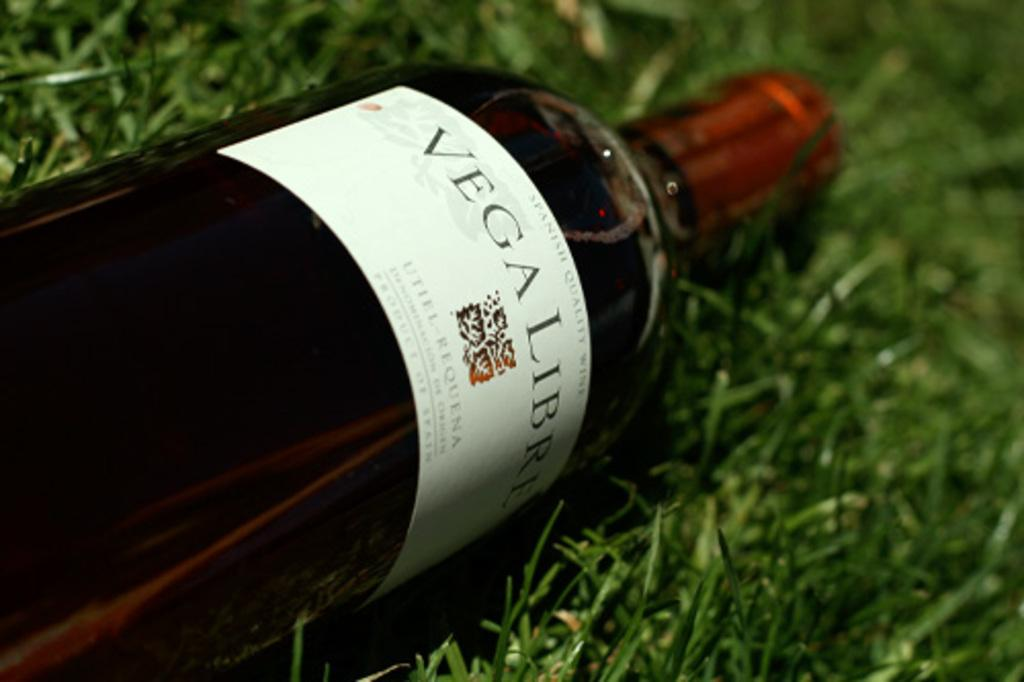What is the main object in the picture? There is a liquor bottle in the picture. What color is the cap of the liquor bottle? The liquor bottle has a red color cap. What type of natural environment can be seen in the picture? There is grass visible in the picture. What type of canvas is being used to paint the thunder in the picture? There is no canvas or painting of thunder present in the picture; it only features a liquor bottle with a red cap and grass. 